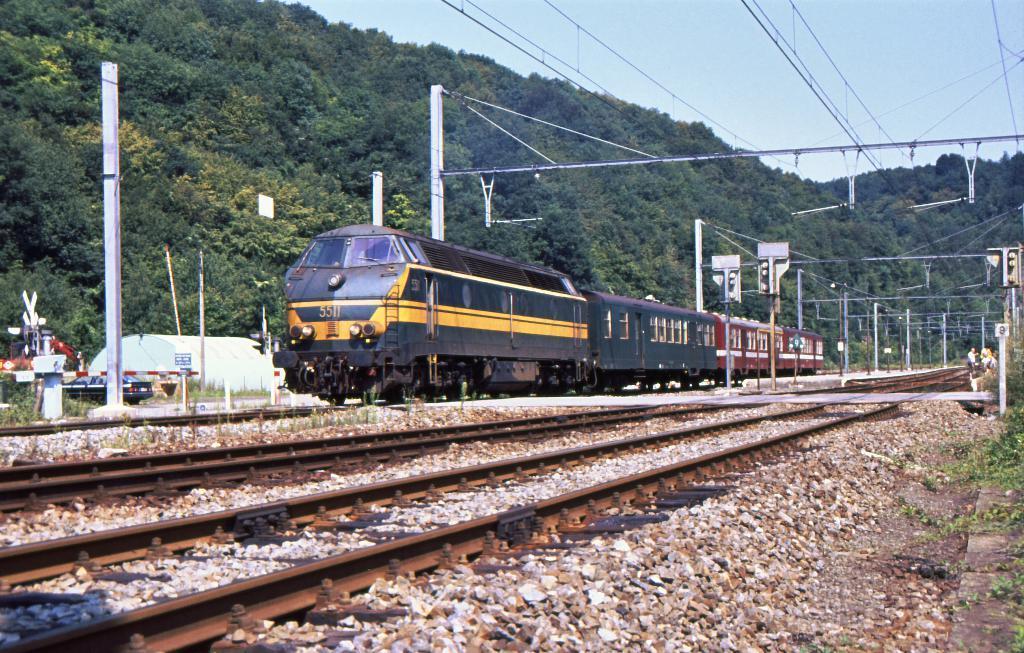Please provide a concise description of this image. In this picture there is a train on the railway track. At the bottom I can see other railway tracks and small stones. On the left I can see the poles, sign boards and other objects. In the background I can see many trees on the mountain. In the top right corner I can see the sky. On the right I can see the electric poles and wires are connected to it. 